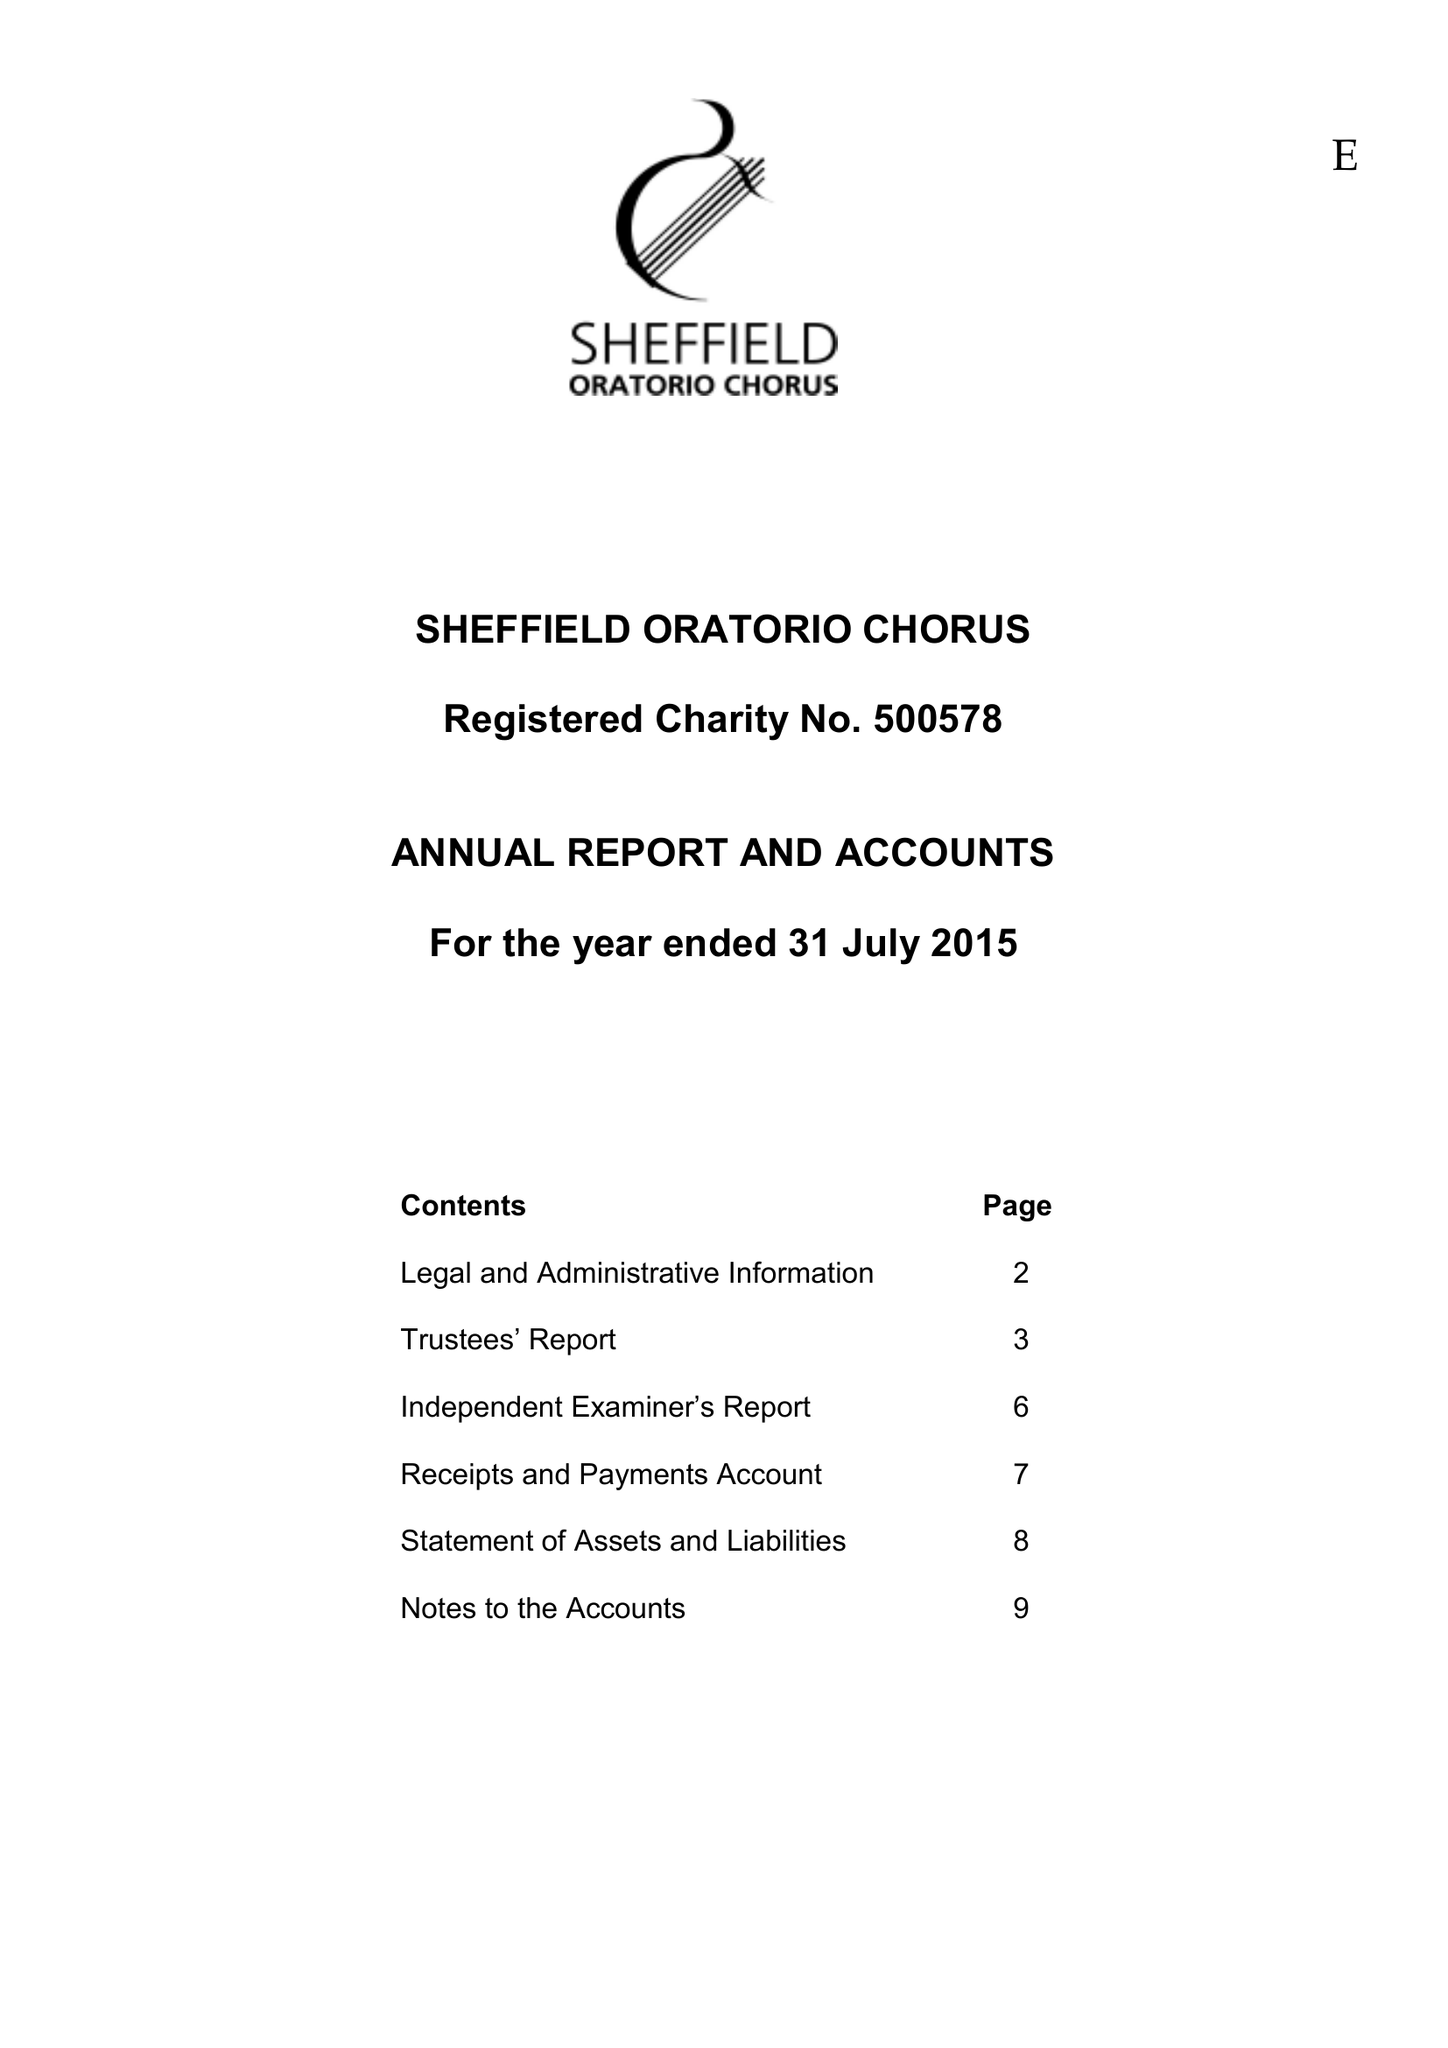What is the value for the charity_name?
Answer the question using a single word or phrase. Sheffield Oratorio Chorus 